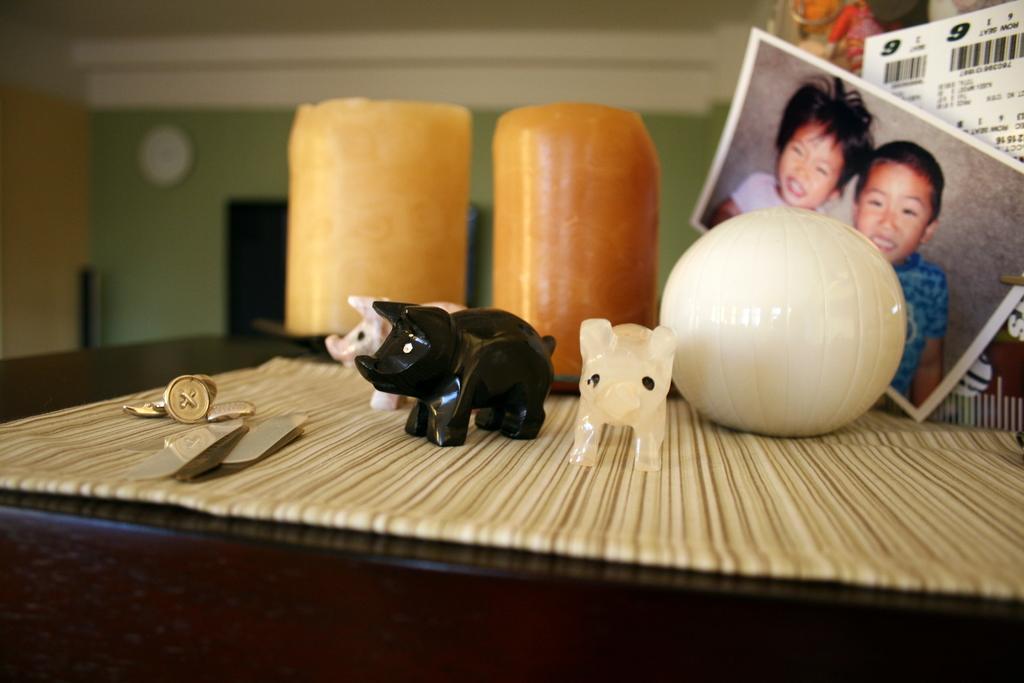Describe this image in one or two sentences. In this image there is a table, on the table there are toys, photo, photos, wall clock on the left side. 